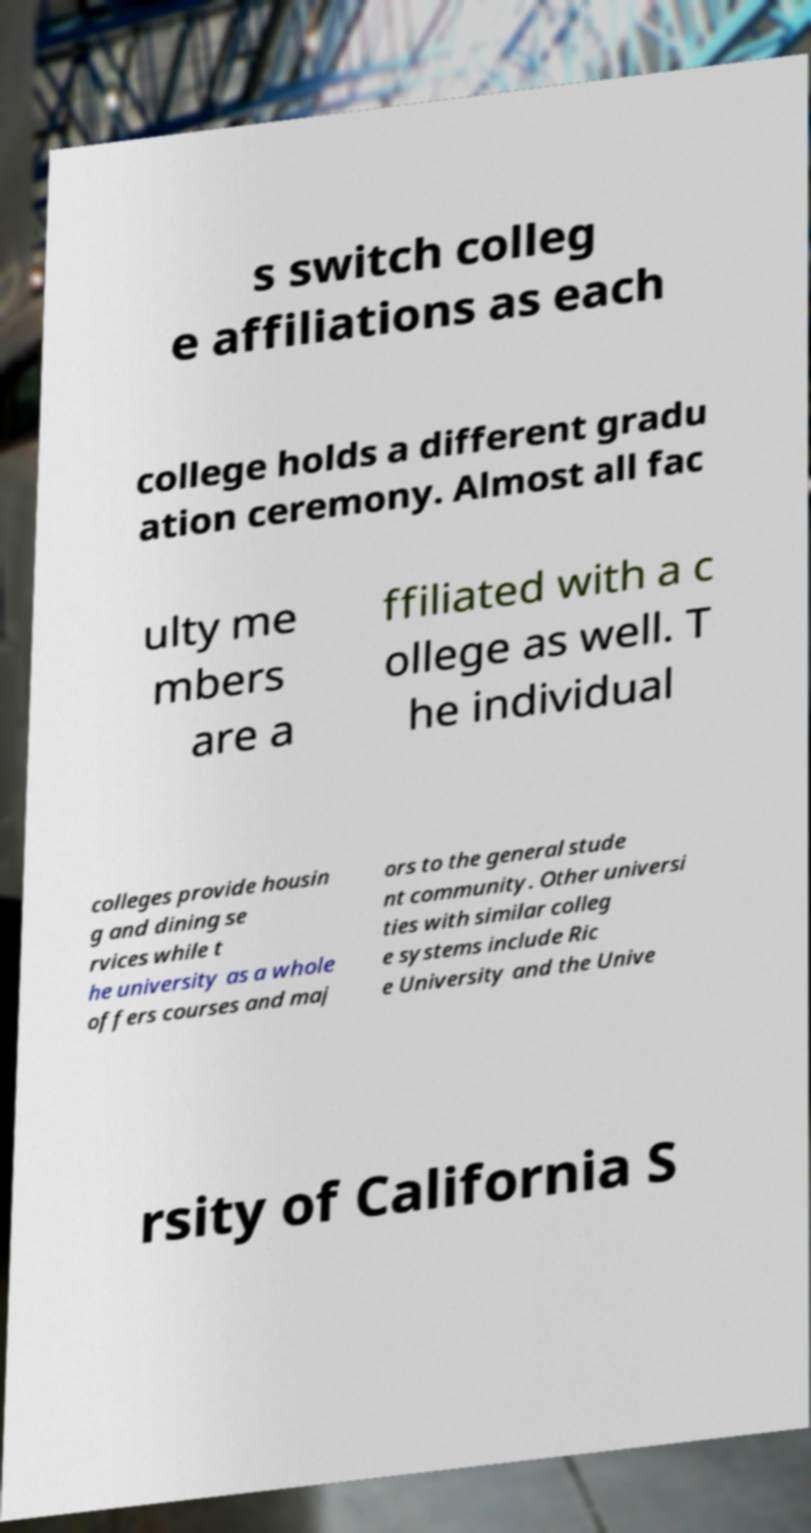Could you extract and type out the text from this image? s switch colleg e affiliations as each college holds a different gradu ation ceremony. Almost all fac ulty me mbers are a ffiliated with a c ollege as well. T he individual colleges provide housin g and dining se rvices while t he university as a whole offers courses and maj ors to the general stude nt community. Other universi ties with similar colleg e systems include Ric e University and the Unive rsity of California S 